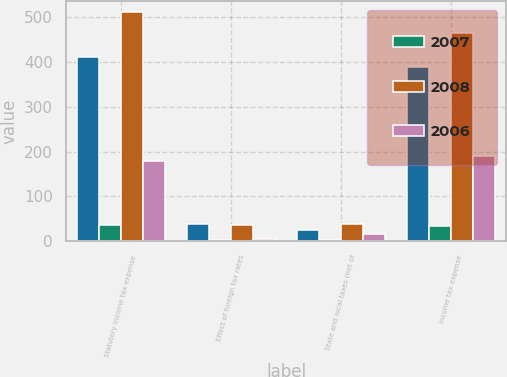Convert chart. <chart><loc_0><loc_0><loc_500><loc_500><stacked_bar_chart><ecel><fcel>Statutory income tax expense<fcel>Effect of foreign tax rates<fcel>State and local taxes (net of<fcel>Income tax expense<nl><fcel>nan<fcel>411<fcel>37<fcel>25<fcel>388<nl><fcel>2007<fcel>35<fcel>3<fcel>2<fcel>33<nl><fcel>2008<fcel>511<fcel>36<fcel>39<fcel>464<nl><fcel>2006<fcel>179<fcel>5<fcel>16<fcel>189<nl></chart> 